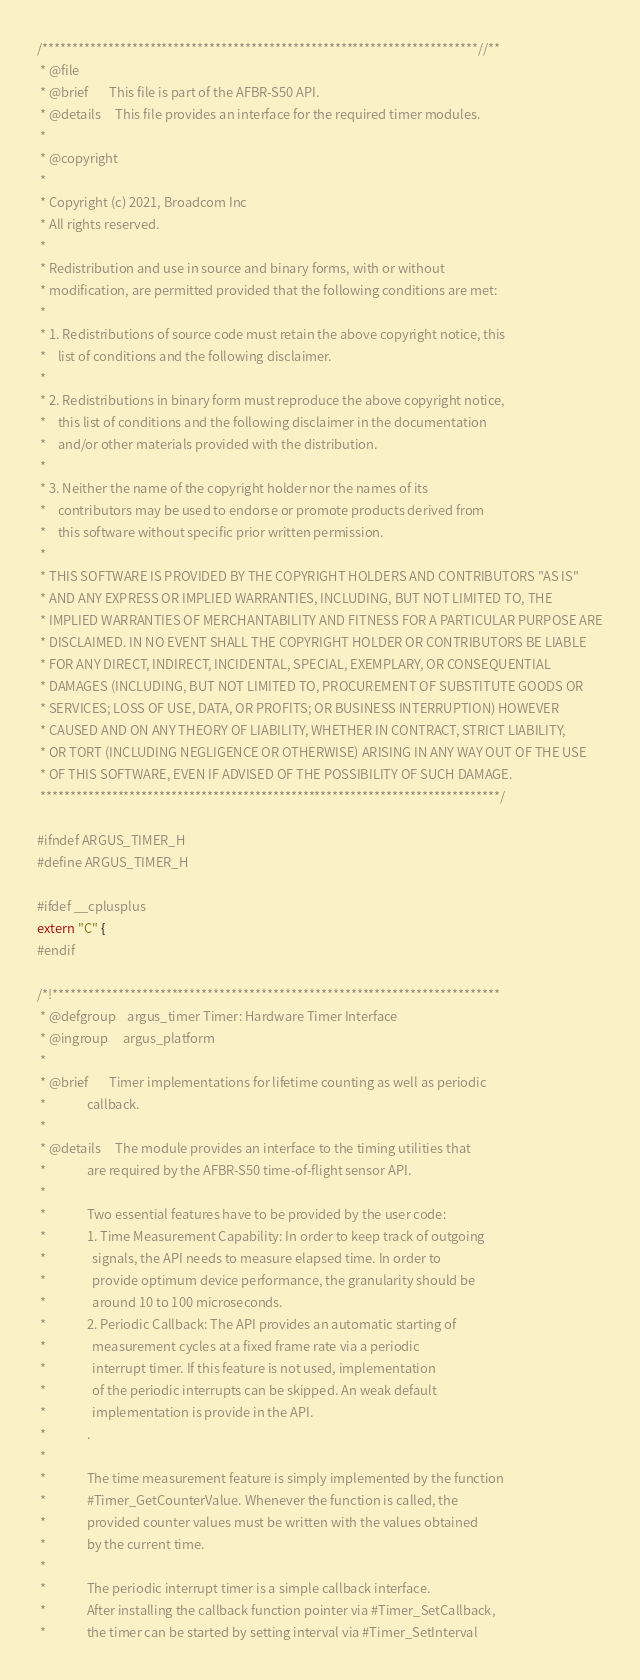<code> <loc_0><loc_0><loc_500><loc_500><_C_>/*************************************************************************//**
 * @file
 * @brief    	This file is part of the AFBR-S50 API.
 * @details		This file provides an interface for the required timer modules.
 *
 * @copyright
 *
 * Copyright (c) 2021, Broadcom Inc
 * All rights reserved.
 *
 * Redistribution and use in source and binary forms, with or without
 * modification, are permitted provided that the following conditions are met:
 *
 * 1. Redistributions of source code must retain the above copyright notice, this
 *    list of conditions and the following disclaimer.
 *
 * 2. Redistributions in binary form must reproduce the above copyright notice,
 *    this list of conditions and the following disclaimer in the documentation
 *    and/or other materials provided with the distribution.
 *
 * 3. Neither the name of the copyright holder nor the names of its
 *    contributors may be used to endorse or promote products derived from
 *    this software without specific prior written permission.
 *
 * THIS SOFTWARE IS PROVIDED BY THE COPYRIGHT HOLDERS AND CONTRIBUTORS "AS IS"
 * AND ANY EXPRESS OR IMPLIED WARRANTIES, INCLUDING, BUT NOT LIMITED TO, THE
 * IMPLIED WARRANTIES OF MERCHANTABILITY AND FITNESS FOR A PARTICULAR PURPOSE ARE
 * DISCLAIMED. IN NO EVENT SHALL THE COPYRIGHT HOLDER OR CONTRIBUTORS BE LIABLE
 * FOR ANY DIRECT, INDIRECT, INCIDENTAL, SPECIAL, EXEMPLARY, OR CONSEQUENTIAL
 * DAMAGES (INCLUDING, BUT NOT LIMITED TO, PROCUREMENT OF SUBSTITUTE GOODS OR
 * SERVICES; LOSS OF USE, DATA, OR PROFITS; OR BUSINESS INTERRUPTION) HOWEVER
 * CAUSED AND ON ANY THEORY OF LIABILITY, WHETHER IN CONTRACT, STRICT LIABILITY,
 * OR TORT (INCLUDING NEGLIGENCE OR OTHERWISE) ARISING IN ANY WAY OUT OF THE USE
 * OF THIS SOFTWARE, EVEN IF ADVISED OF THE POSSIBILITY OF SUCH DAMAGE.
 *****************************************************************************/

#ifndef ARGUS_TIMER_H
#define ARGUS_TIMER_H

#ifdef __cplusplus
extern "C" {
#endif

/*!***************************************************************************
 * @defgroup	argus_timer Timer: Hardware Timer Interface
 * @ingroup		argus_platform
 *
 * @brief 		Timer implementations for lifetime counting as well as periodic
 * 				callback.
 *
 * @details		The module provides an interface to the timing utilities that
 * 				are required by the AFBR-S50 time-of-flight sensor API.
 *
 *				Two essential features have to be provided by the user code:
 *				1. Time Measurement Capability: In order to keep track of outgoing
 *				  signals, the API needs to measure elapsed time. In order to
 *				  provide optimum device performance, the granularity should be
 *				  around 10 to 100 microseconds.
 *				2. Periodic Callback: The API provides an automatic starting of
 *				  measurement cycles at a fixed frame rate via a periodic
 *				  interrupt timer. If this feature is not used, implementation
 *				  of the periodic interrupts can be skipped. An weak default
 *				  implementation is provide in the API.
 *				.
 *
 *				The time measurement feature is simply implemented by the function
 *				#Timer_GetCounterValue. Whenever the function is called, the
 *				provided counter values must be written with the values obtained
 *				by the current time.
 *
 *				The periodic interrupt timer is a simple callback interface.
 *				After installing the callback function pointer via #Timer_SetCallback,
 *				the timer can be started by setting interval via #Timer_SetInterval</code> 